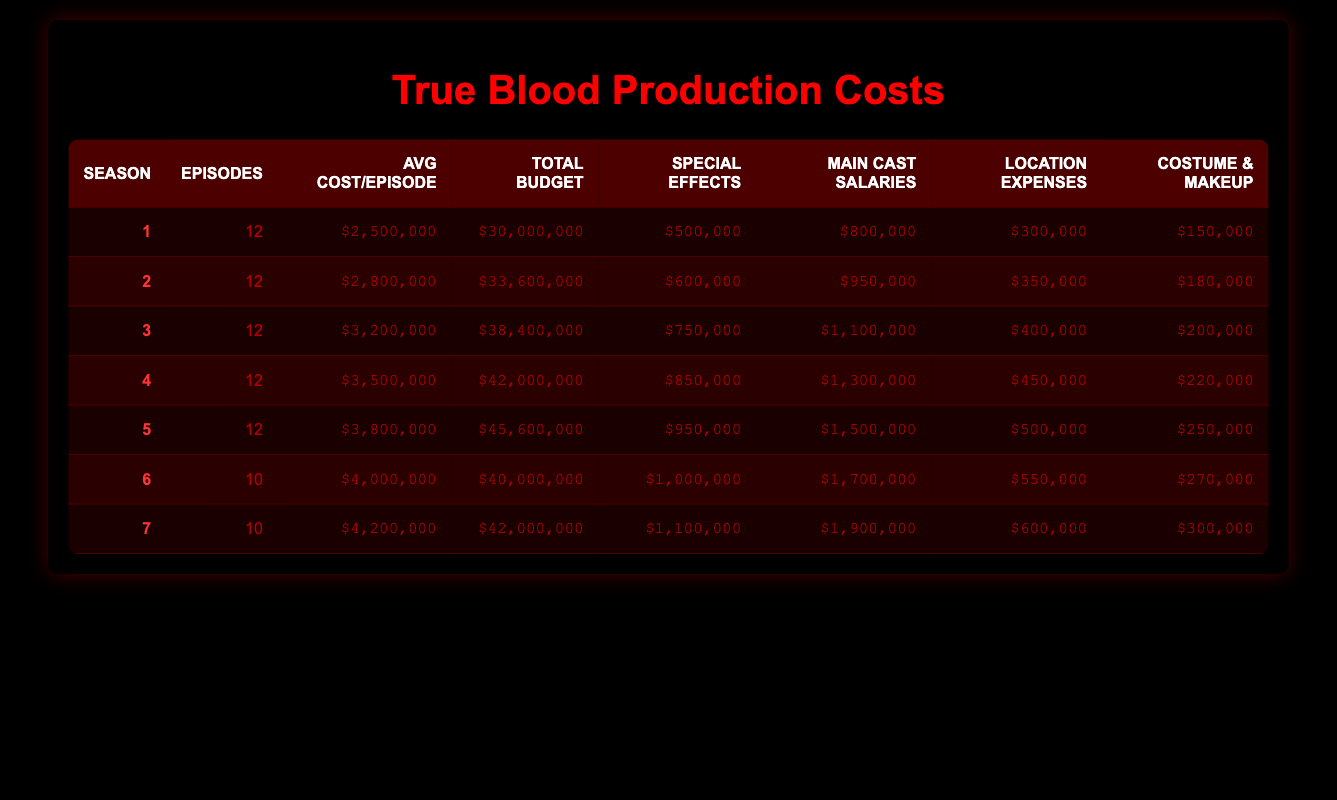What was the average cost per episode for season 3? The average cost per episode for season 3 is directly provided in the table, which shows that it was $3,200,000.
Answer: $3,200,000 How many episodes were produced in season 6? The table indicates that season 6 consisted of 10 episodes, as shown in the 'Episodes' column for that season.
Answer: 10 What is the total budget for season 5? The total budget for season 5 can be found directly in the table, where it states that the total season budget was $45,600,000.
Answer: $45,600,000 Did the average cost per episode increase every season? By looking at the average cost per episode for each season in the table, it is evident that the costs increased consistently from season 1 ($2,500,000) to season 5 ($3,800,000) and continued rising in season 6 ($4,000,000) and season 7 ($4,200,000). Thus, the statement is true.
Answer: Yes What was the combined special effects cost for seasons 1 and 2? The special effects costs for seasons 1 and 2 are $500,000 and $600,000, respectively. By adding these together (500,000 + 600,000), the total special effects cost for both seasons amounts to $1,100,000.
Answer: $1,100,000 Which season had the highest main cast salaries, and what was the amount? Upon examining the table, season 7 has the highest main cast salaries listed at $1,900,000.
Answer: Season 7, $1,900,000 What was the difference in total season budget between seasons 4 and 5? From the table, the total season budget for season 4 is $42,000,000, and for season 5, it is $45,600,000. The difference is calculated by subtracting season 4's budget from season 5's budget: $45,600,000 - $42,000,000 = $3,600,000.
Answer: $3,600,000 What was the average costume and makeup budget across all seasons? The costume and makeup budgets for the seasons are $150,000, $180,000, $200,000, $220,000, $250,000, $270,000, and $300,000, respectively. To find the average, first sum these amounts: 150000 + 180000 + 200000 + 220000 + 250000 + 270000 + 300000 = 1,570,000. There are 7 seasons, so the average is 1,570,000 / 7 = 224,285.71. Rounding, we say the average is approximately $224,286.
Answer: $224,286 